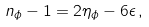<formula> <loc_0><loc_0><loc_500><loc_500>n _ { \phi } - 1 = 2 \eta _ { \phi } - 6 \epsilon \, ,</formula> 